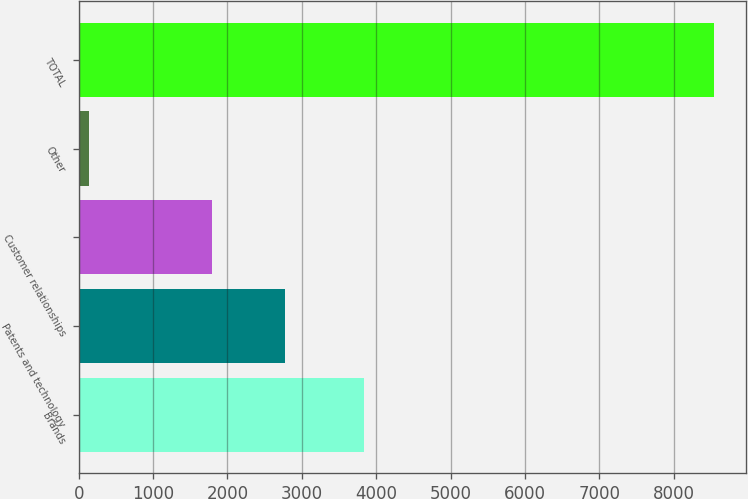Convert chart. <chart><loc_0><loc_0><loc_500><loc_500><bar_chart><fcel>Brands<fcel>Patents and technology<fcel>Customer relationships<fcel>Other<fcel>TOTAL<nl><fcel>3836<fcel>2776<fcel>1787<fcel>145<fcel>8544<nl></chart> 